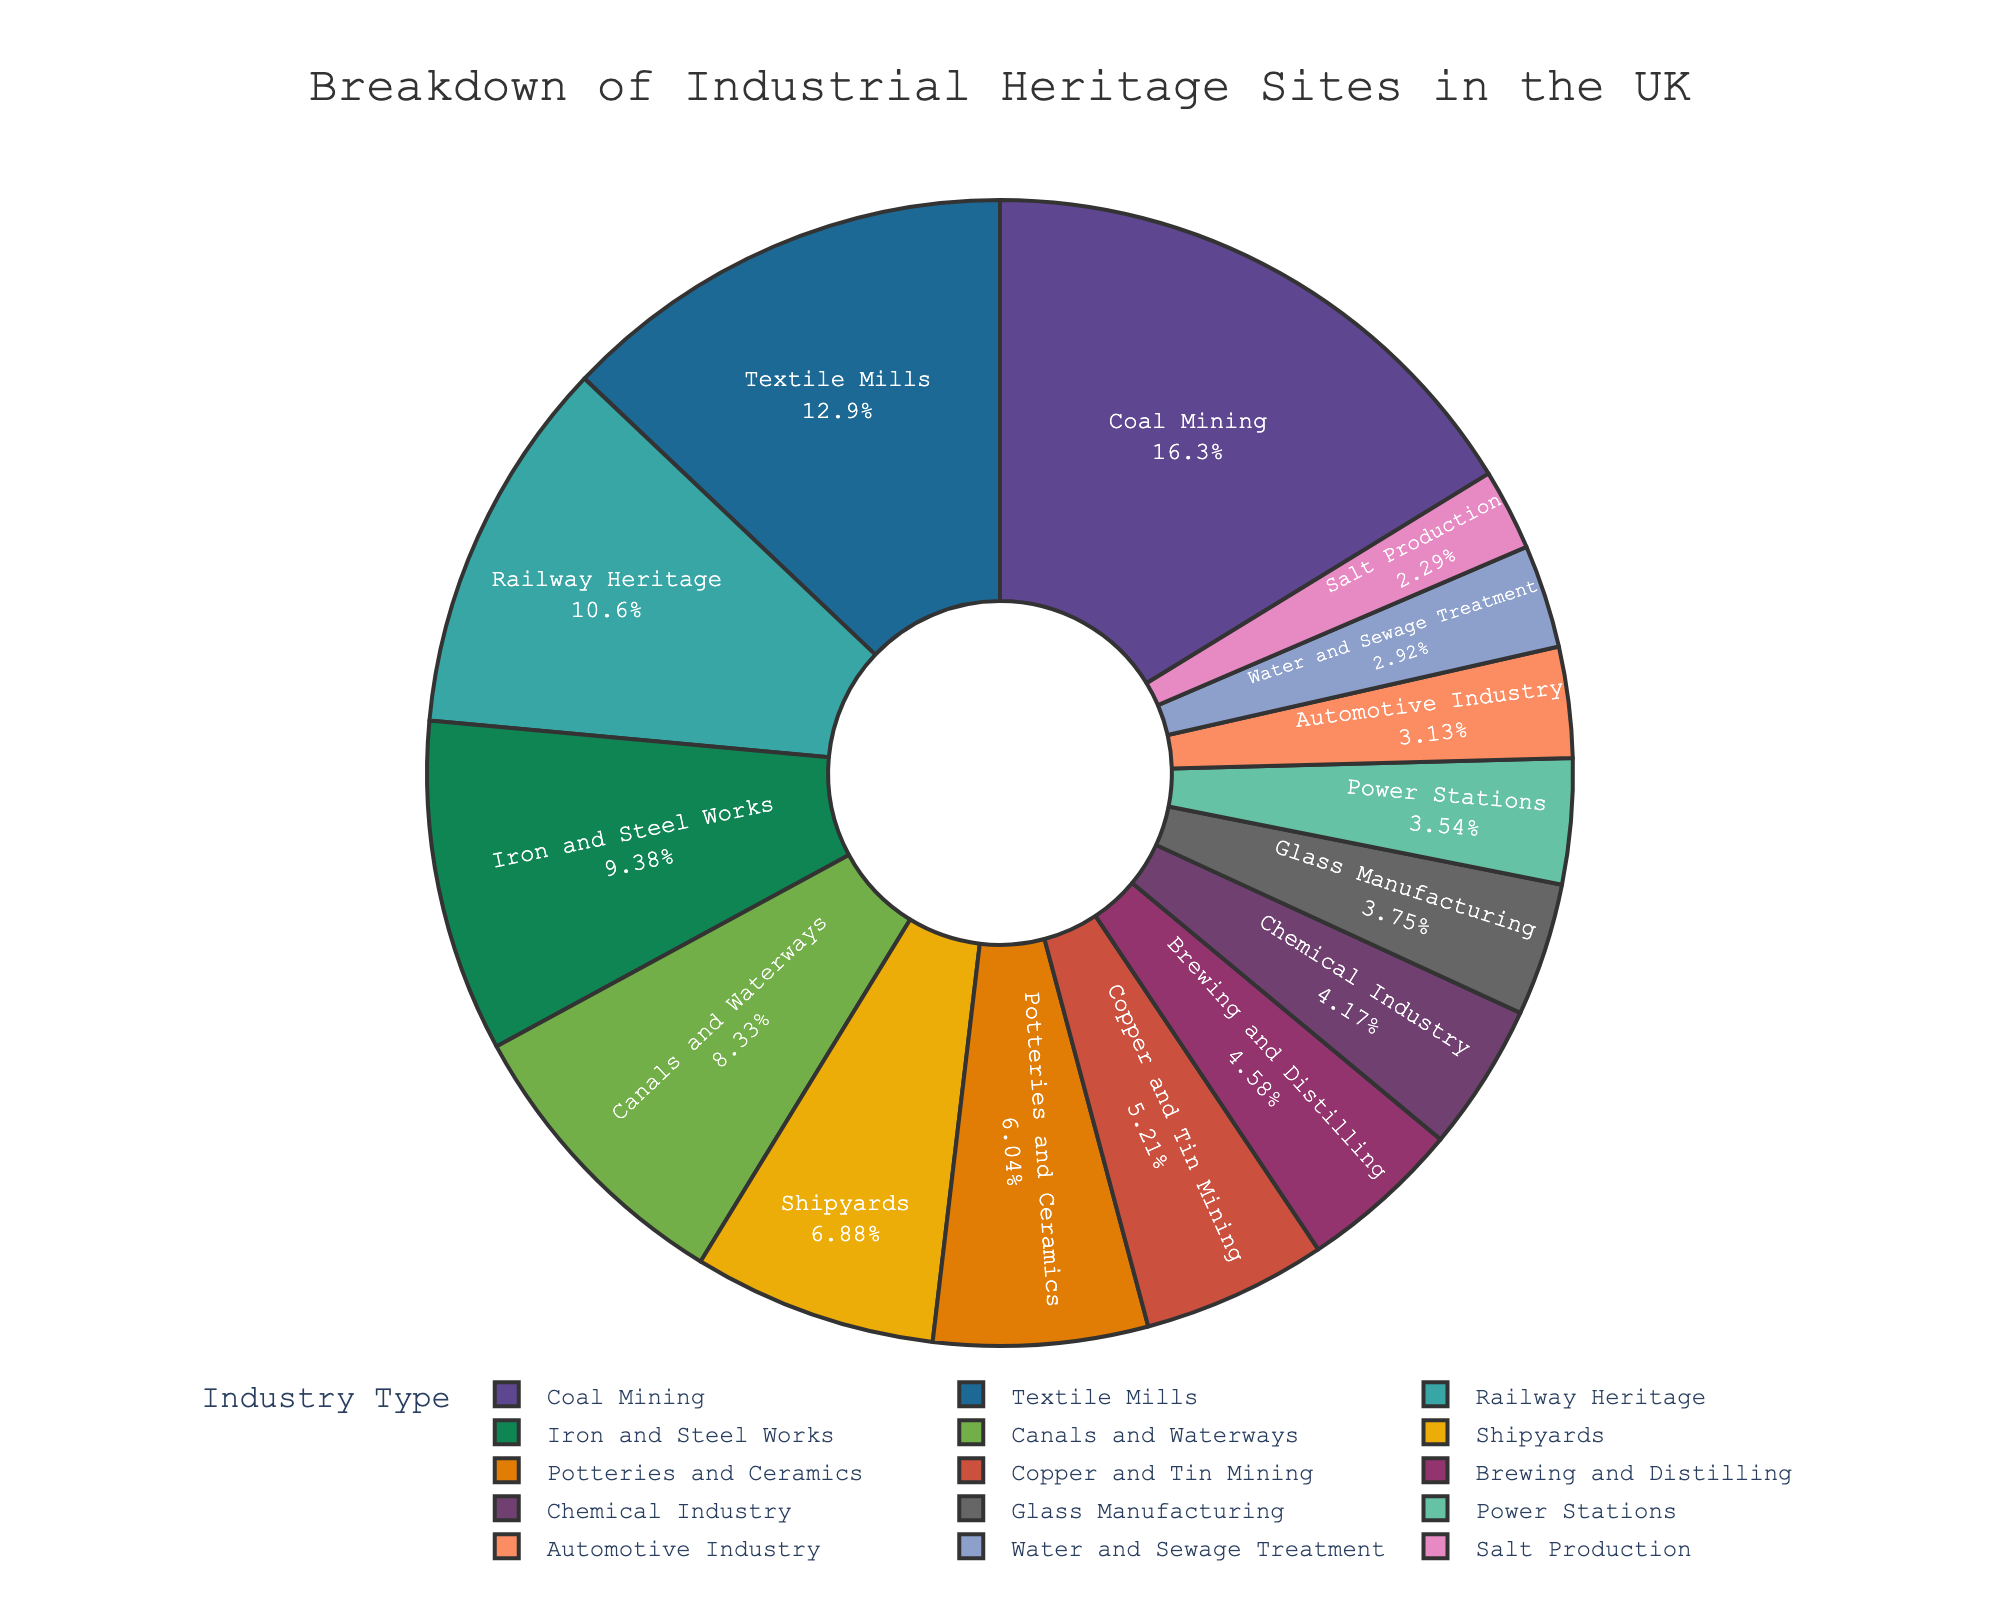What's the industry type with the highest number of sites? The slice labeled "Coal Mining" takes up the largest portion of the pie chart. By referencing this visual cue and checking the number, it is clear that "Coal Mining" has 78 sites, which is the highest.
Answer: Coal Mining Which industry types have more than 50 sites each? The industry types with more than 50 sites each are represented by larger slices clearly labeled in the pie chart. The ones meeting this criterion are "Coal Mining" (78 sites), "Textile Mills" (62 sites), and "Railway Heritage" (51 sites).
Answer: Coal Mining, Textile Mills, Railway Heritage How many total sites are represented by the categories of "Shipyards," "Potteries and Ceramics," and "Copper and Tin Mining"? To find the total number of sites for these categories, sum their respective numbers: Shipyards (33) + Potteries and Ceramics (29) + Copper and Tin Mining (25). Thus, 33 + 29 + 25 = 87.
Answer: 87 Compare the number of "Canals and Waterways" sites to "Automotive Industry" sites. Which has more and by how many? "Canals and Waterways" have 40 sites whereas "Automotive Industry" has 15 sites. To find out how many more sites "Canals and Waterways" has, calculate 40 - 15 = 25.
Answer: Canals and Waterways have 25 more sites Which industry type occupies the smallest portion of the pie chart and how many sites does it have? The smallest slice of the pie chart corresponds to "Salt Production". By checking the data, "Salt Production" has 11 sites.
Answer: Salt Production, 11 sites How do the combined number of "Brewing and Distilling" and "Glass Manufacturing" sites compare to "Textile Mills" sites? Add the sites for "Brewing and Distilling" (22) and "Glass Manufacturing" (18) to get 22 + 18 = 40, then compare this to the "Textile Mills" sites which are 62. 40 is less than 62.
Answer: Less (40 vs. 62) What is the average number of sites for "Chemical Industry," "Power Stations," and "Water and Sewage Treatment"? Compute the average by summing the sites for "Chemical Industry" (20), "Power Stations" (17), and "Water and Sewage Treatment" (14) and then dividing by 3: (20 + 17 + 14) / 3 = 17.
Answer: 17 What percentage of the total sites do "Iron and Steel Works" represent? Find the total number of sites by summing all categories. Then, calculate the percentage for "Iron and Steel Works" by (number of Iron and Steel Works sites / total sites) * 100. The percentage is displayed directly in the pie chart as well.
Answer: 13.1% 